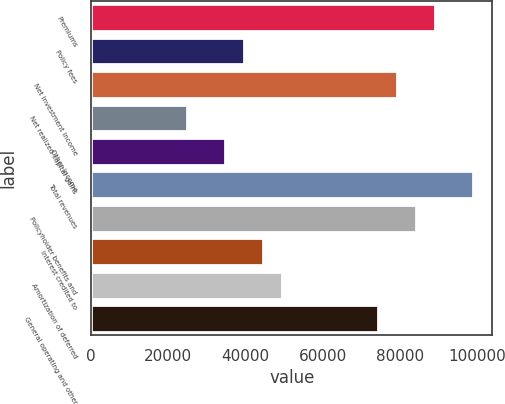<chart> <loc_0><loc_0><loc_500><loc_500><bar_chart><fcel>Premiums<fcel>Policy fees<fcel>Net investment income<fcel>Net realized capital gains<fcel>Other income<fcel>Total revenues<fcel>Policyholder benefits and<fcel>Interest credited to<fcel>Amortization of deferred<fcel>General operating and other<nl><fcel>89134.9<fcel>39616.2<fcel>79231.2<fcel>24760.6<fcel>34664.4<fcel>99038.7<fcel>84183.1<fcel>44568.1<fcel>49520<fcel>74279.3<nl></chart> 